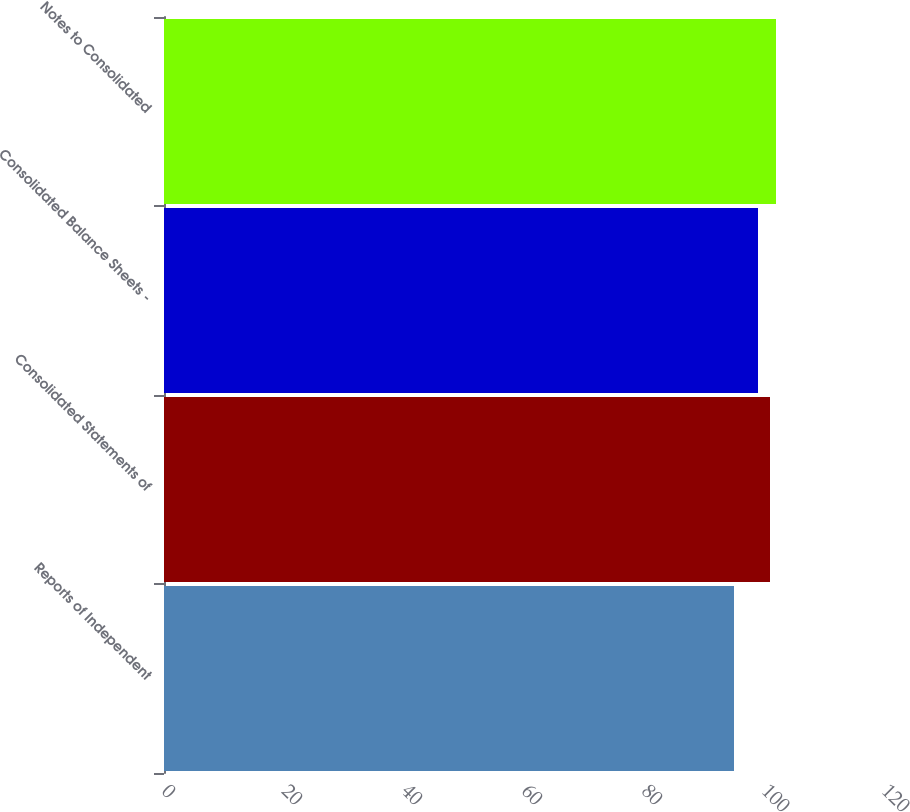<chart> <loc_0><loc_0><loc_500><loc_500><bar_chart><fcel>Reports of Independent<fcel>Consolidated Statements of<fcel>Consolidated Balance Sheets -<fcel>Notes to Consolidated<nl><fcel>95<fcel>101<fcel>99<fcel>102<nl></chart> 